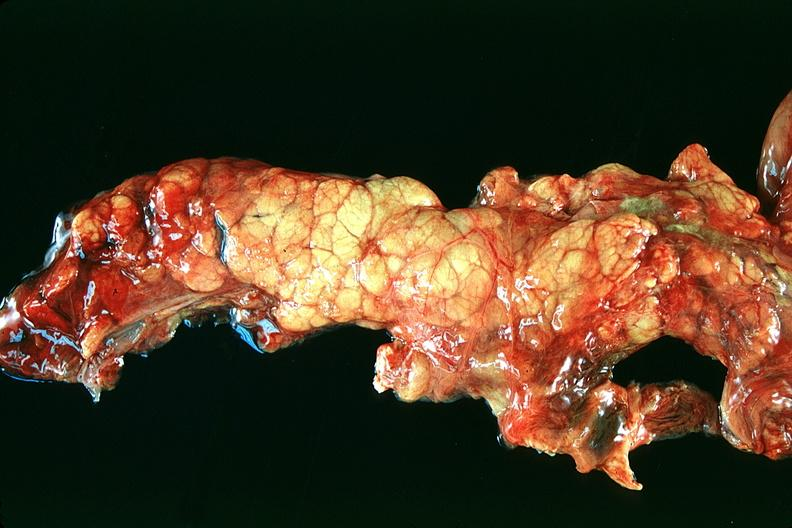does this image show normal pancreas?
Answer the question using a single word or phrase. Yes 